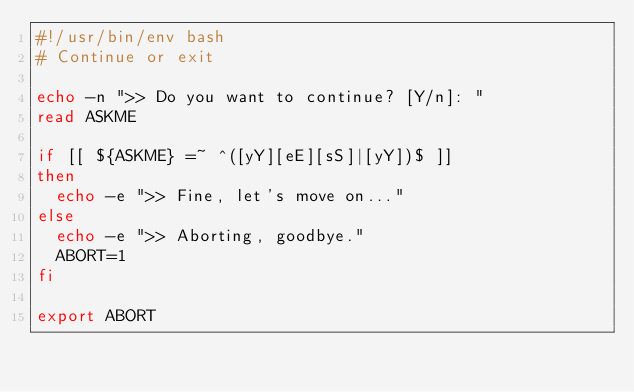<code> <loc_0><loc_0><loc_500><loc_500><_Bash_>#!/usr/bin/env bash
# Continue or exit

echo -n ">> Do you want to continue? [Y/n]: "
read ASKME

if [[ ${ASKME} =~ ^([yY][eE][sS]|[yY])$ ]]
then
  echo -e ">> Fine, let's move on..."
else
  echo -e ">> Aborting, goodbye."
  ABORT=1
fi

export ABORT
</code> 